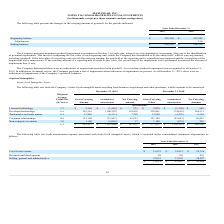According to Maxlinear's financial document, How does Goodwill arise from? Based on the financial document, the answer is the acquisition method of accounting for business combinations and represents the excess of the purchase price over the fair value of the net assets and other identifiable intangible assets acquired.. Also, When does the company perform an annual goodwill impairment assessment? According to the financial document, October 31st. The relevant text states: "forms an annual goodwill impairment assessment on October 31st each year, using a two-step quantitative assessment. Step one is the identification..." Also, What were the adjustments in 2018? According to the financial document, 338 (in thousands). The relevant text states: "Adjustments — 338..." Also, can you calculate: What was the change in the Beginning balance from 2018 to 2019? Based on the calculation: 238,330 - 237,992, the result is 338 (in thousands). This is based on the information: "Beginning balance $ 238,330 $ 237,992 Beginning balance $ 238,330 $ 237,992..." The key data points involved are: 237,992, 238,330. Also, can you calculate: What is the average adjustments for 2018 and 2019? To answer this question, I need to perform calculations using the financial data. The calculation is: (0 + 338) / 2, which equals 169 (in thousands). This is based on the information: "Adjustments — 338 2019 2018..." The key data points involved are: 0, 338. Additionally, In which year was the ending balance less than 240,000 thousands? The document shows two values: 2019 and 2018. Locate and analyze ending balance in row 6. From the document: "2019 2018 2019 2018..." 